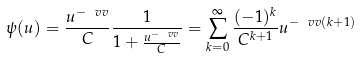<formula> <loc_0><loc_0><loc_500><loc_500>\psi ( u ) = \frac { u ^ { - \ v v } } { C } \frac { 1 } { 1 + \frac { u ^ { - \ v v } } { C } } = \sum _ { k = 0 } ^ { \infty } \frac { ( - 1 ) ^ { k } } { C ^ { k + 1 } } u ^ { - \ v v ( k + 1 ) }</formula> 